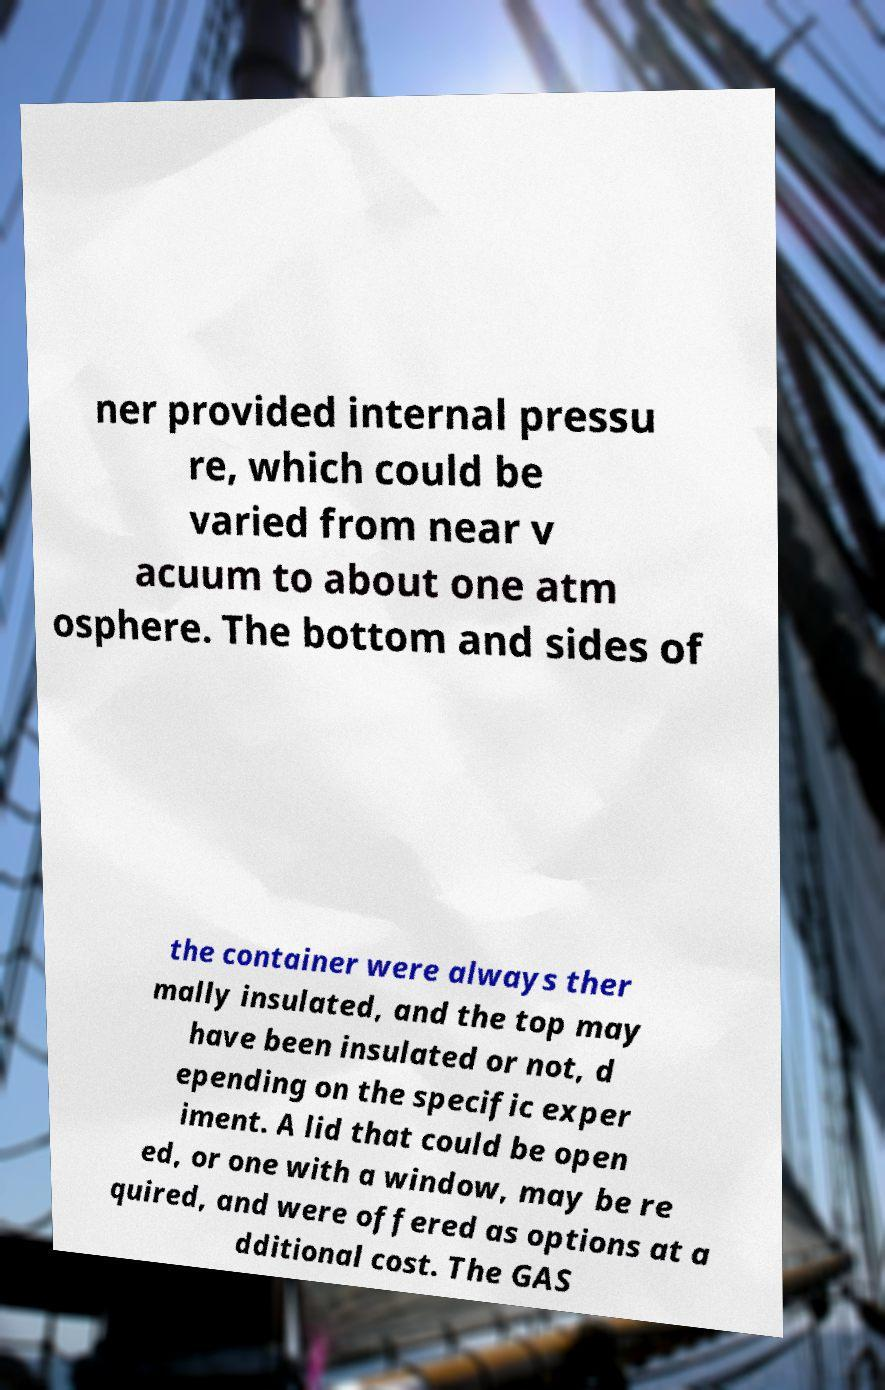Please identify and transcribe the text found in this image. ner provided internal pressu re, which could be varied from near v acuum to about one atm osphere. The bottom and sides of the container were always ther mally insulated, and the top may have been insulated or not, d epending on the specific exper iment. A lid that could be open ed, or one with a window, may be re quired, and were offered as options at a dditional cost. The GAS 